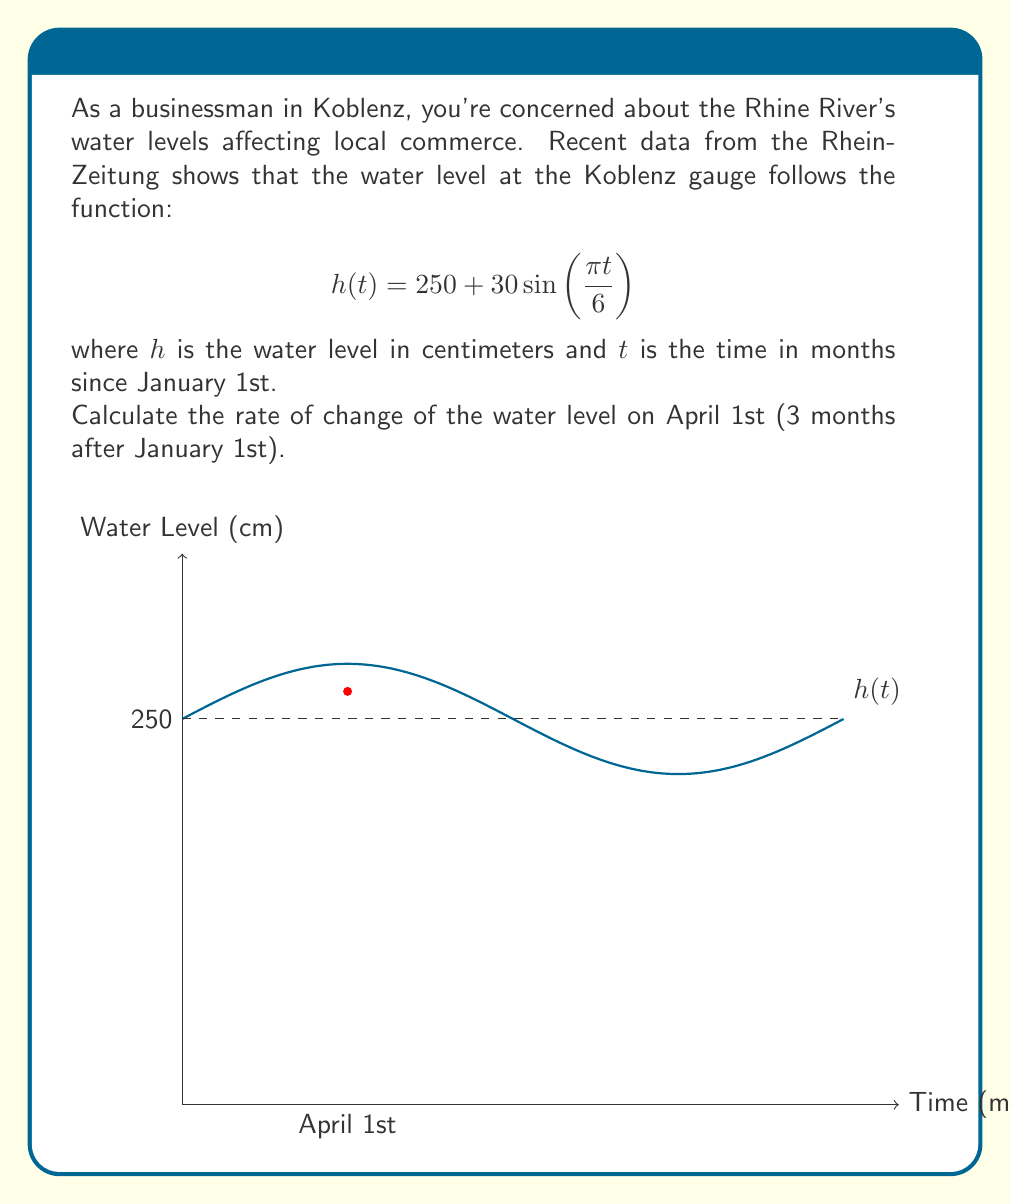What is the answer to this math problem? To find the rate of change, we need to calculate the derivative of $h(t)$ and evaluate it at $t=3$. Let's break this down step-by-step:

1) The given function is:
   $$h(t) = 250 + 30\sin(\frac{\pi t}{6})$$

2) To find the derivative, we use the chain rule:
   $$h'(t) = 30 \cdot \cos(\frac{\pi t}{6}) \cdot \frac{\pi}{6}$$

3) Simplify:
   $$h'(t) = 5\pi \cos(\frac{\pi t}{6})$$

4) Now, we need to evaluate this at $t=3$:
   $$h'(3) = 5\pi \cos(\frac{\pi \cdot 3}{6})$$

5) Simplify the argument of cosine:
   $$h'(3) = 5\pi \cos(\frac{\pi}{2})$$

6) We know that $\cos(\frac{\pi}{2}) = 0$, so:
   $$h'(3) = 5\pi \cdot 0 = 0$$

Therefore, the rate of change of the water level on April 1st is 0 cm/month.
Answer: $0$ cm/month 